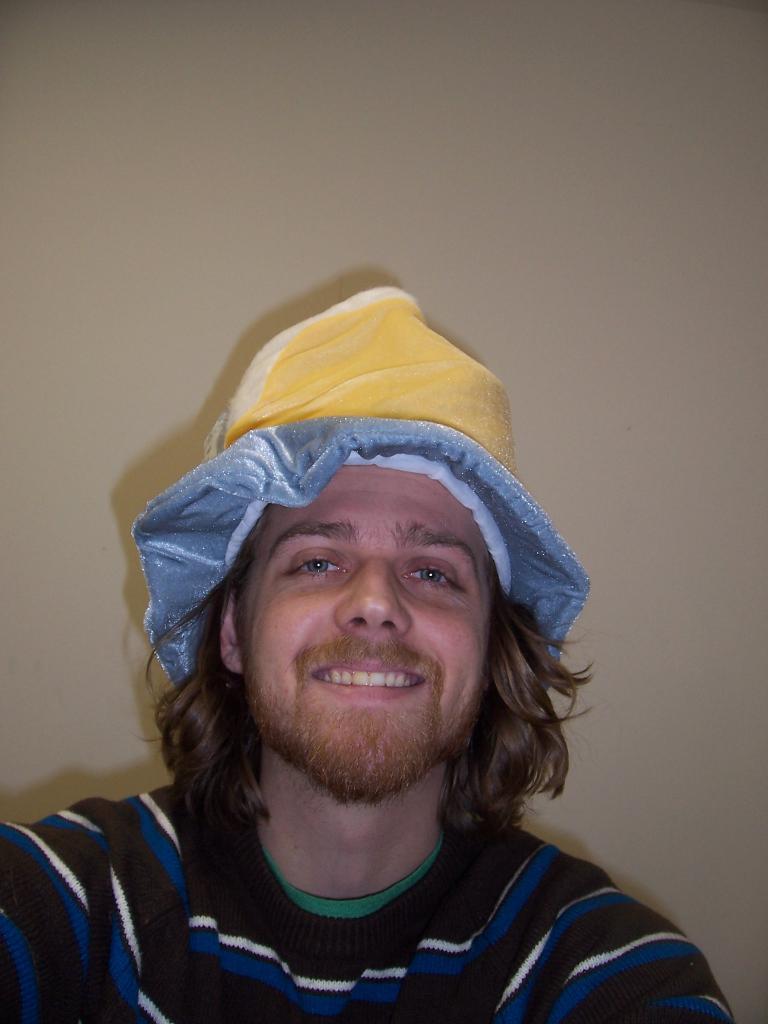Describe this image in one or two sentences. In this picture we can see a man wore a cap and smiling and in the background we can see the wall. 